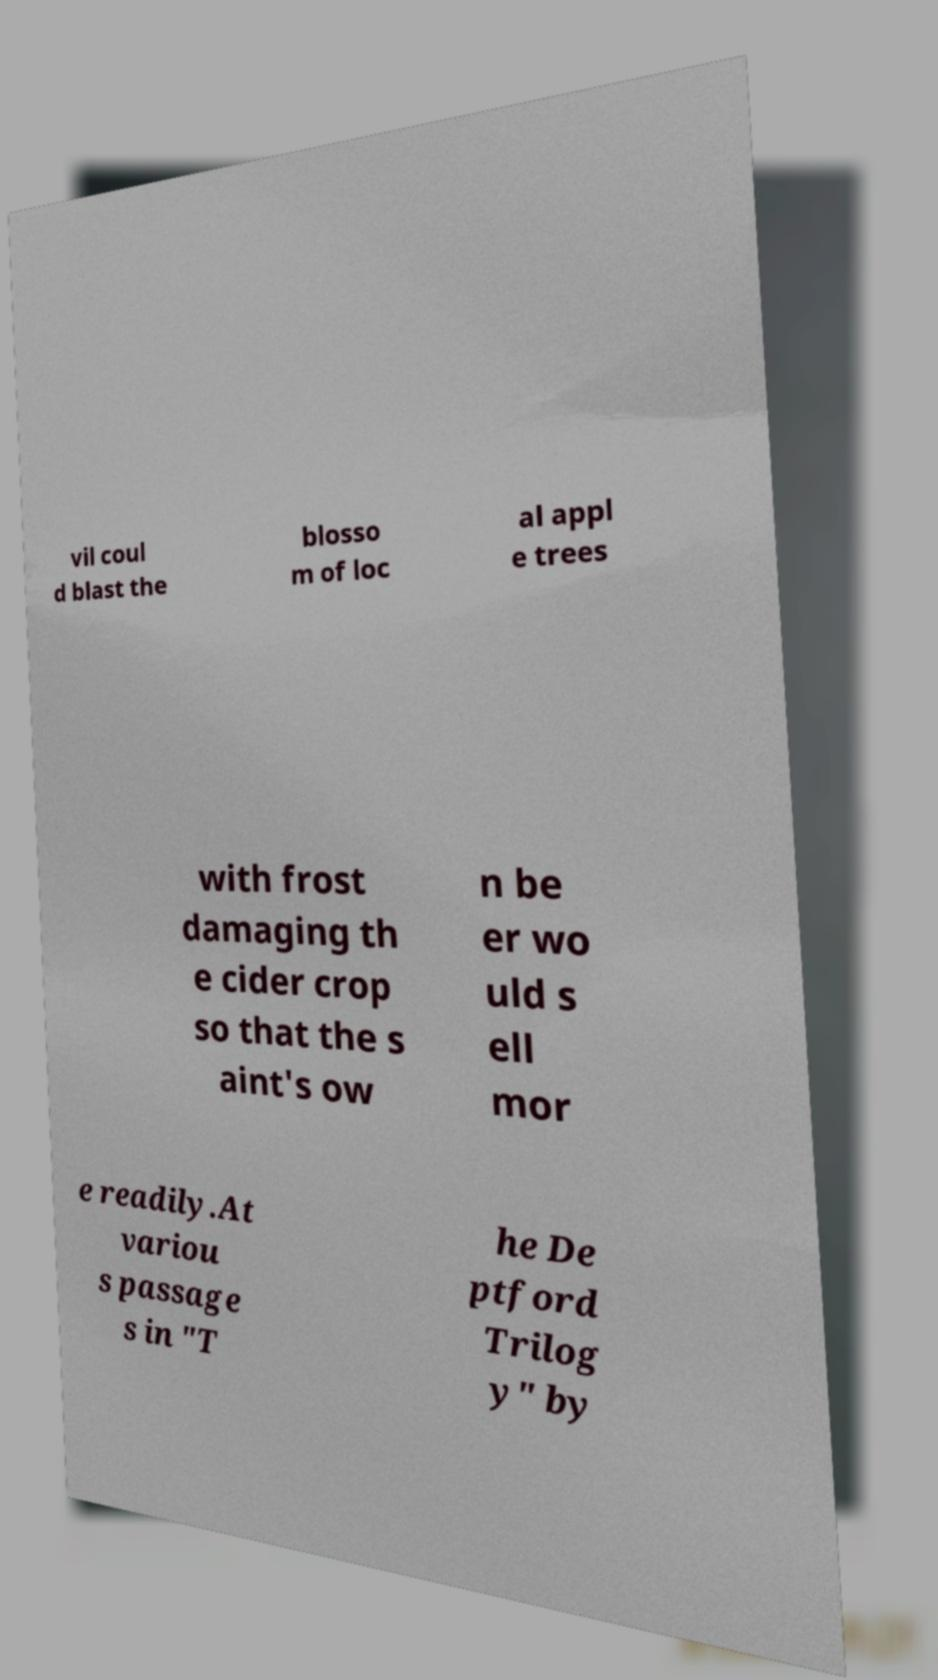There's text embedded in this image that I need extracted. Can you transcribe it verbatim? vil coul d blast the blosso m of loc al appl e trees with frost damaging th e cider crop so that the s aint's ow n be er wo uld s ell mor e readily.At variou s passage s in "T he De ptford Trilog y" by 